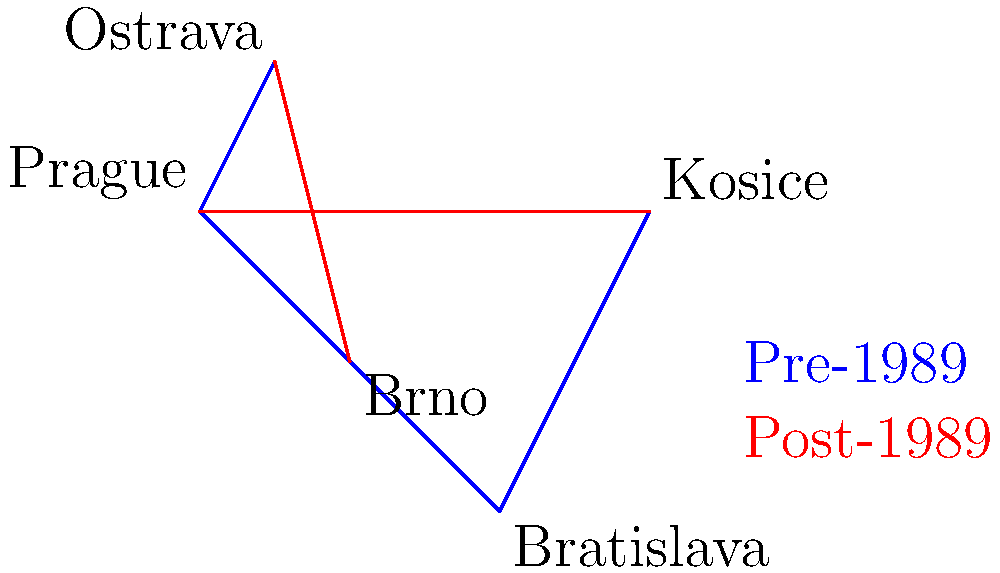In the diagram, blue lines represent major transportation routes between Czechoslovakian cities before the Velvet Revolution, while red lines show new connections established after 1989. How did the topological structure of the transportation network change, and what does this suggest about the socio-economic shifts in the country post-revolution? To analyze the topological changes in the transportation network:

1. Pre-1989 structure:
   - Linear connection: Prague - Brno - Bratislava - Kosice
   - Separate connection: Prague - Ostrava
   - Network diameter (longest path): 3 edges (Prague to Kosice)

2. Post-1989 additions:
   - Direct connection: Prague - Kosice
   - New link: Brno - Ostrava

3. Topological changes:
   - Creation of cycles: Prague - Brno - Ostrava - Prague and Prague - Brno - Bratislava - Kosice - Prague
   - Reduced network diameter: 2 edges (direct Prague-Kosice link)
   - Increased connectivity: More alternative routes between cities

4. Socio-economic implications:
   - Decentralization: New connections bypass the linear structure, reducing dependence on intermediate cities
   - Economic integration: Direct Prague-Kosice link suggests stronger ties between Czech and Slovak regions
   - Regional development: Brno-Ostrava connection indicates focus on developing links between secondary cities
   - Efficiency: Shorter paths between major cities suggest improved transportation and communication

The topological changes reflect a shift from a centralized, linear structure to a more interconnected, efficient network, indicating economic liberalization and regional integration post-revolution.
Answer: Decentralization and increased connectivity, reflecting economic liberalization and regional integration. 